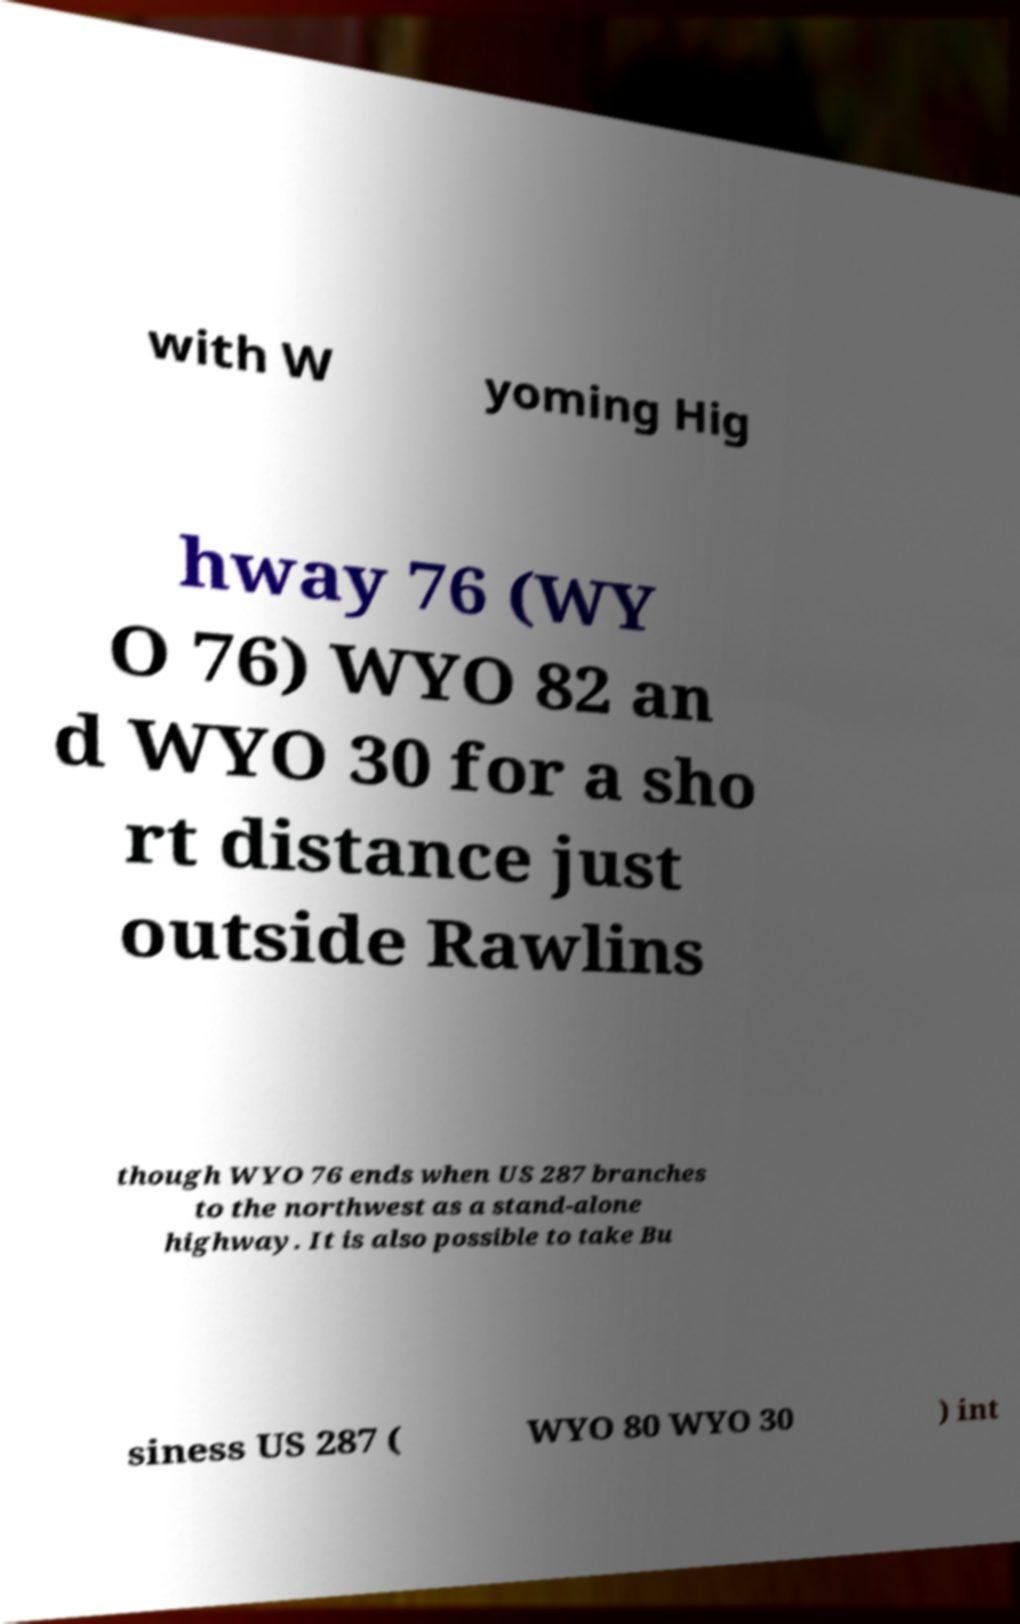For documentation purposes, I need the text within this image transcribed. Could you provide that? with W yoming Hig hway 76 (WY O 76) WYO 82 an d WYO 30 for a sho rt distance just outside Rawlins though WYO 76 ends when US 287 branches to the northwest as a stand-alone highway. It is also possible to take Bu siness US 287 ( WYO 80 WYO 30 ) int 